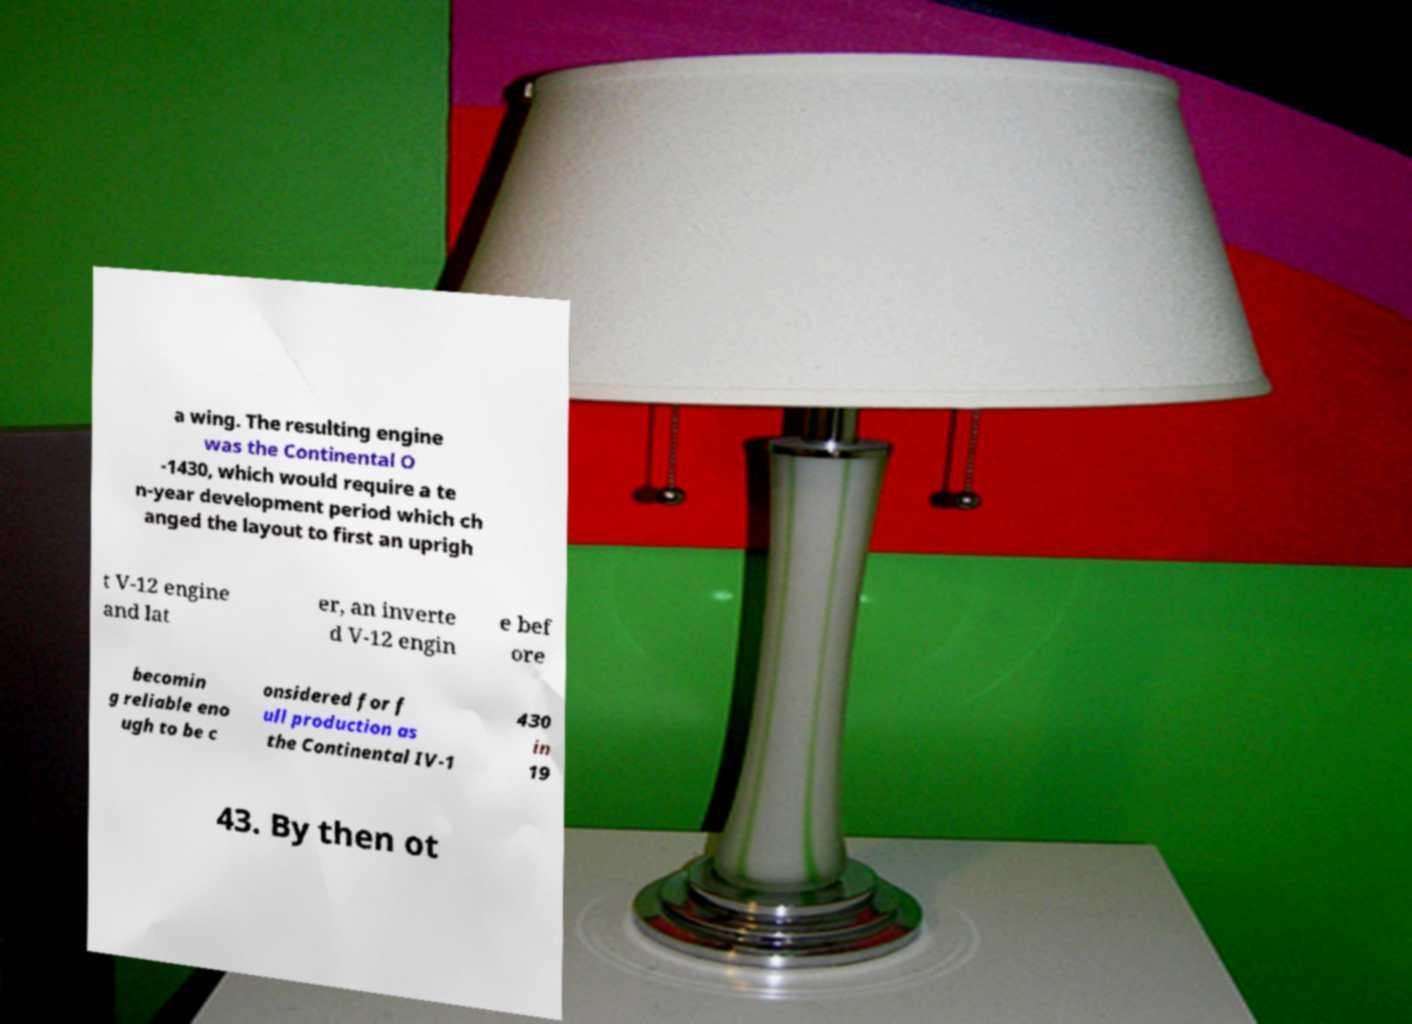I need the written content from this picture converted into text. Can you do that? a wing. The resulting engine was the Continental O -1430, which would require a te n-year development period which ch anged the layout to first an uprigh t V-12 engine and lat er, an inverte d V-12 engin e bef ore becomin g reliable eno ugh to be c onsidered for f ull production as the Continental IV-1 430 in 19 43. By then ot 